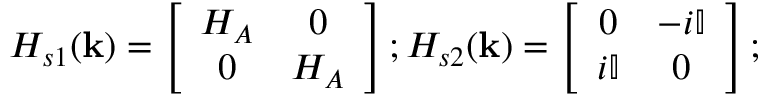<formula> <loc_0><loc_0><loc_500><loc_500>H _ { s 1 } ( { k } ) = \left [ \begin{array} { c c } { H _ { A } } & { 0 } \\ { 0 } & { H _ { A } } \end{array} \right ] ; H _ { s 2 } ( { k } ) = \left [ \begin{array} { c c } { 0 } & { - i \mathbb { I } } \\ { i \mathbb { I } } & { 0 } \end{array} \right ] ;</formula> 